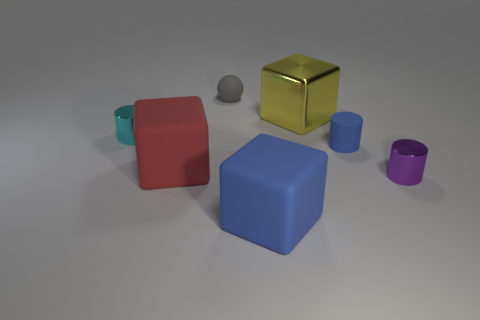The block that is the same color as the small matte cylinder is what size?
Your response must be concise. Large. What is the material of the blue cylinder that is the same size as the gray matte thing?
Provide a short and direct response. Rubber. Is the size of the metal cylinder that is in front of the red rubber object the same as the block behind the small blue thing?
Give a very brief answer. No. Are there any gray spheres that have the same material as the purple object?
Provide a short and direct response. No. How many objects are either metal cylinders that are left of the gray matte sphere or large shiny objects?
Your answer should be compact. 2. Is the material of the cylinder that is left of the gray sphere the same as the ball?
Keep it short and to the point. No. Is the yellow object the same shape as the big blue matte object?
Your answer should be very brief. Yes. There is a tiny cylinder that is on the left side of the red matte cube; how many cylinders are on the left side of it?
Keep it short and to the point. 0. There is a large red object that is the same shape as the big blue thing; what is it made of?
Your answer should be compact. Rubber. There is a rubber object that is in front of the purple shiny object; is it the same color as the tiny rubber cylinder?
Offer a very short reply. Yes. 